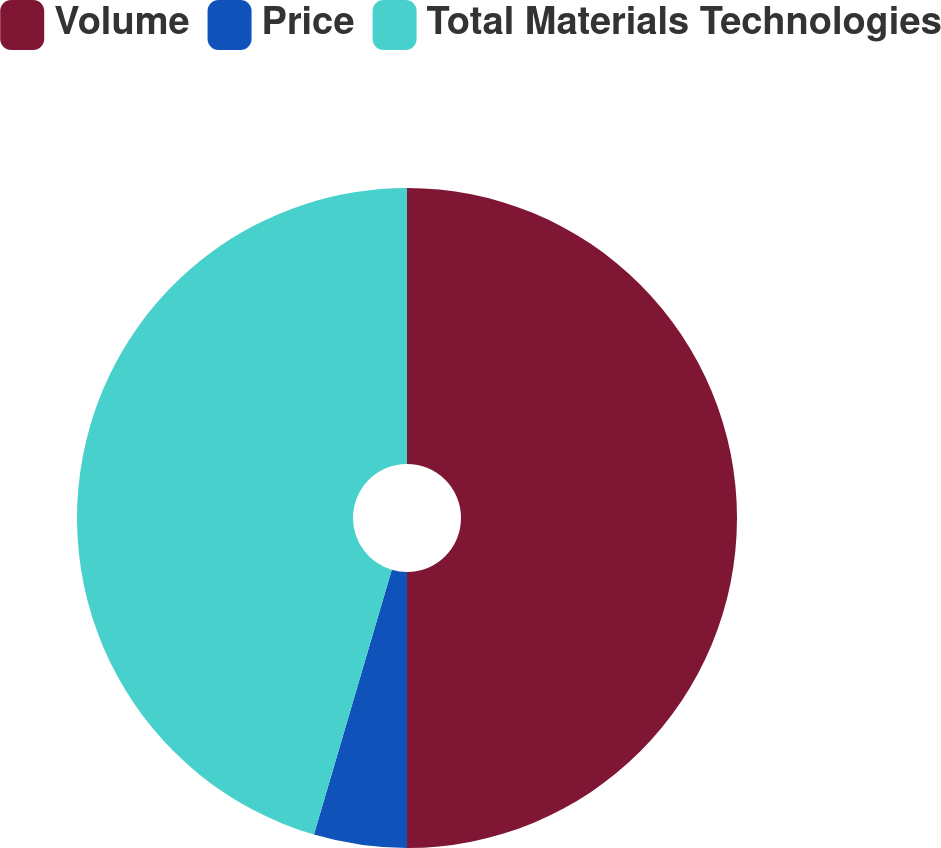<chart> <loc_0><loc_0><loc_500><loc_500><pie_chart><fcel>Volume<fcel>Price<fcel>Total Materials Technologies<nl><fcel>50.0%<fcel>4.55%<fcel>45.45%<nl></chart> 